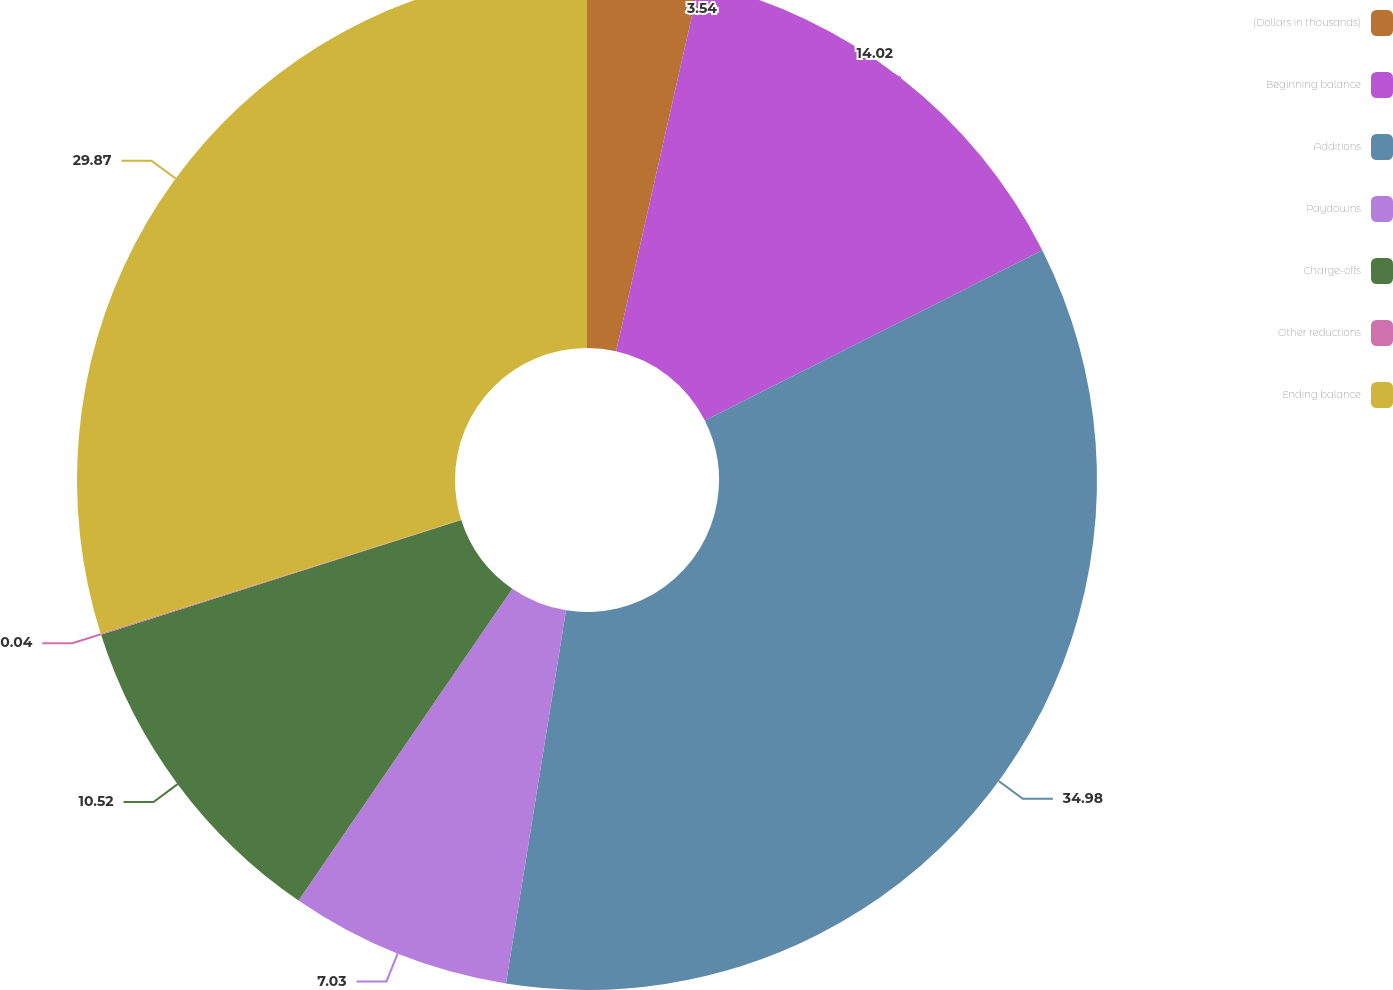<chart> <loc_0><loc_0><loc_500><loc_500><pie_chart><fcel>(Dollars in thousands)<fcel>Beginning balance<fcel>Additions<fcel>Paydowns<fcel>Charge-offs<fcel>Other reductions<fcel>Ending balance<nl><fcel>3.54%<fcel>14.02%<fcel>34.98%<fcel>7.03%<fcel>10.52%<fcel>0.04%<fcel>29.87%<nl></chart> 